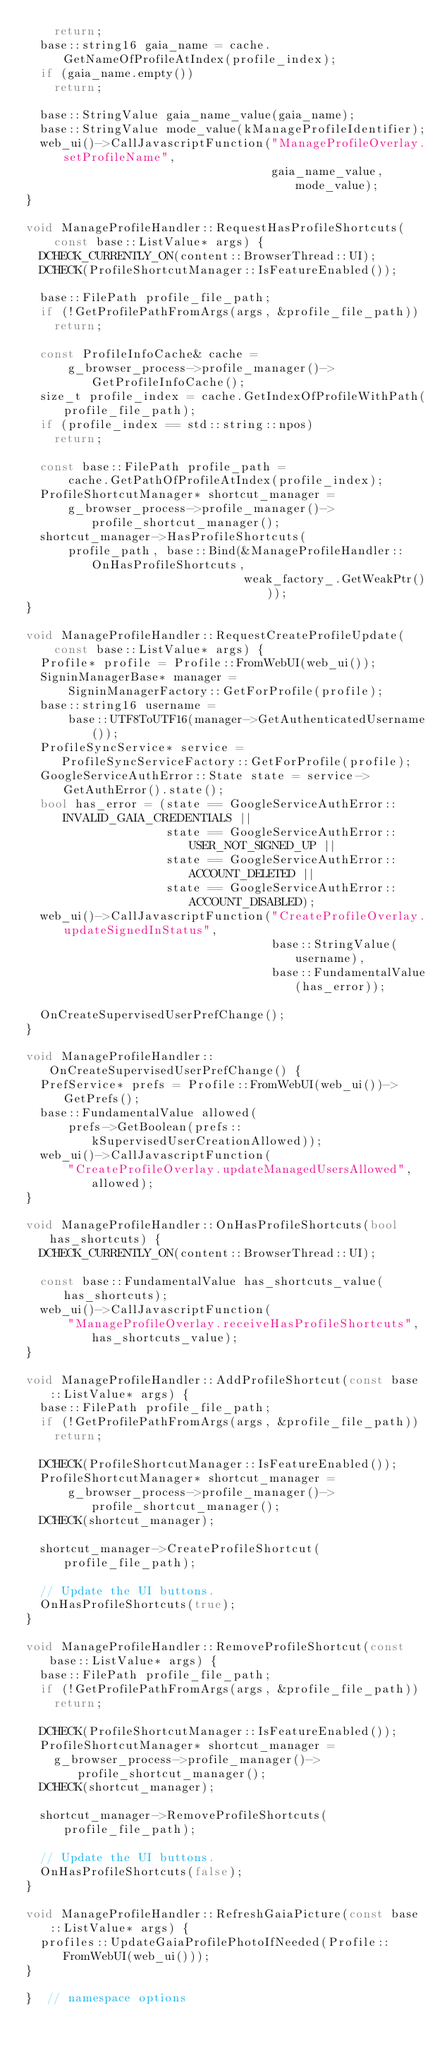Convert code to text. <code><loc_0><loc_0><loc_500><loc_500><_C++_>    return;
  base::string16 gaia_name = cache.GetNameOfProfileAtIndex(profile_index);
  if (gaia_name.empty())
    return;

  base::StringValue gaia_name_value(gaia_name);
  base::StringValue mode_value(kManageProfileIdentifier);
  web_ui()->CallJavascriptFunction("ManageProfileOverlay.setProfileName",
                                   gaia_name_value, mode_value);
}

void ManageProfileHandler::RequestHasProfileShortcuts(
    const base::ListValue* args) {
  DCHECK_CURRENTLY_ON(content::BrowserThread::UI);
  DCHECK(ProfileShortcutManager::IsFeatureEnabled());

  base::FilePath profile_file_path;
  if (!GetProfilePathFromArgs(args, &profile_file_path))
    return;

  const ProfileInfoCache& cache =
      g_browser_process->profile_manager()->GetProfileInfoCache();
  size_t profile_index = cache.GetIndexOfProfileWithPath(profile_file_path);
  if (profile_index == std::string::npos)
    return;

  const base::FilePath profile_path =
      cache.GetPathOfProfileAtIndex(profile_index);
  ProfileShortcutManager* shortcut_manager =
      g_browser_process->profile_manager()->profile_shortcut_manager();
  shortcut_manager->HasProfileShortcuts(
      profile_path, base::Bind(&ManageProfileHandler::OnHasProfileShortcuts,
                               weak_factory_.GetWeakPtr()));
}

void ManageProfileHandler::RequestCreateProfileUpdate(
    const base::ListValue* args) {
  Profile* profile = Profile::FromWebUI(web_ui());
  SigninManagerBase* manager =
      SigninManagerFactory::GetForProfile(profile);
  base::string16 username =
      base::UTF8ToUTF16(manager->GetAuthenticatedUsername());
  ProfileSyncService* service =
     ProfileSyncServiceFactory::GetForProfile(profile);
  GoogleServiceAuthError::State state = service->GetAuthError().state();
  bool has_error = (state == GoogleServiceAuthError::INVALID_GAIA_CREDENTIALS ||
                    state == GoogleServiceAuthError::USER_NOT_SIGNED_UP ||
                    state == GoogleServiceAuthError::ACCOUNT_DELETED ||
                    state == GoogleServiceAuthError::ACCOUNT_DISABLED);
  web_ui()->CallJavascriptFunction("CreateProfileOverlay.updateSignedInStatus",
                                   base::StringValue(username),
                                   base::FundamentalValue(has_error));

  OnCreateSupervisedUserPrefChange();
}

void ManageProfileHandler::OnCreateSupervisedUserPrefChange() {
  PrefService* prefs = Profile::FromWebUI(web_ui())->GetPrefs();
  base::FundamentalValue allowed(
      prefs->GetBoolean(prefs::kSupervisedUserCreationAllowed));
  web_ui()->CallJavascriptFunction(
      "CreateProfileOverlay.updateManagedUsersAllowed", allowed);
}

void ManageProfileHandler::OnHasProfileShortcuts(bool has_shortcuts) {
  DCHECK_CURRENTLY_ON(content::BrowserThread::UI);

  const base::FundamentalValue has_shortcuts_value(has_shortcuts);
  web_ui()->CallJavascriptFunction(
      "ManageProfileOverlay.receiveHasProfileShortcuts", has_shortcuts_value);
}

void ManageProfileHandler::AddProfileShortcut(const base::ListValue* args) {
  base::FilePath profile_file_path;
  if (!GetProfilePathFromArgs(args, &profile_file_path))
    return;

  DCHECK(ProfileShortcutManager::IsFeatureEnabled());
  ProfileShortcutManager* shortcut_manager =
      g_browser_process->profile_manager()->profile_shortcut_manager();
  DCHECK(shortcut_manager);

  shortcut_manager->CreateProfileShortcut(profile_file_path);

  // Update the UI buttons.
  OnHasProfileShortcuts(true);
}

void ManageProfileHandler::RemoveProfileShortcut(const base::ListValue* args) {
  base::FilePath profile_file_path;
  if (!GetProfilePathFromArgs(args, &profile_file_path))
    return;

  DCHECK(ProfileShortcutManager::IsFeatureEnabled());
  ProfileShortcutManager* shortcut_manager =
    g_browser_process->profile_manager()->profile_shortcut_manager();
  DCHECK(shortcut_manager);

  shortcut_manager->RemoveProfileShortcuts(profile_file_path);

  // Update the UI buttons.
  OnHasProfileShortcuts(false);
}

void ManageProfileHandler::RefreshGaiaPicture(const base::ListValue* args) {
  profiles::UpdateGaiaProfilePhotoIfNeeded(Profile::FromWebUI(web_ui()));
}

}  // namespace options
</code> 